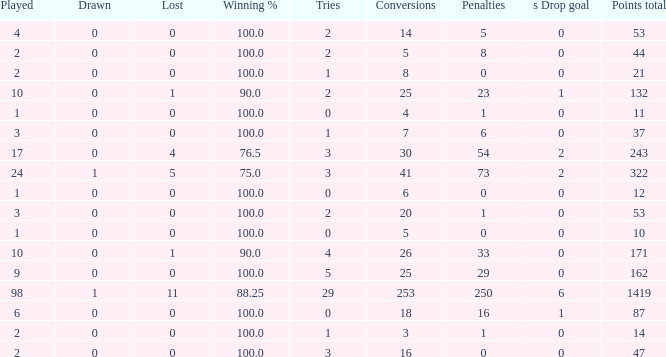What is the least number of penalties he got when his point total was over 1419 in more than 98 games? None. 